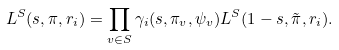<formula> <loc_0><loc_0><loc_500><loc_500>L ^ { S } ( s , \pi , r _ { i } ) = \prod _ { v \in S } \gamma _ { i } ( s , \pi _ { v } , \psi _ { v } ) L ^ { S } ( 1 - s , { \tilde { \pi } } , r _ { i } ) .</formula> 